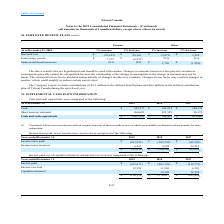From Loral Space Communications's financial document, How much does the company expect to make contributions to to the defined benefit plans and the defined contribution plan respectively during the next fiscal year? The document shows two values: $5.1 million and $0.6 million. From the document: "s of $5.1 million to the defined benefit plans and $0.6 million to the defined contribution The Company expects to make contributions of $5.1 million ..." Also, How much would the pension change if there is a 1% increase and a 1% decrease respectively in the discount rate? The document shows two values: $(39,145) and $49,361. From the document: "Discount rate $ (39,145) $ 49,361 $ (2,471) $ 3,224 Discount rate $ (39,145) $ 49,361 $ (2,471) $ 3,224..." Also, How much would the pension change if there is a 1% increase and a 1% decrease respectively in the future salary growth? The document shows two values: $7,572 and $(6,919). From the document: "Future salary growth $ 7,572 $ (6,919) N/A N/A Future salary growth $ 7,572 $ (6,919) N/A N/A..." Also, can you calculate: What is the value of the expected defined contribution plan as a percentage of the defined benefit plan during the next fiscal year? Based on the calculation: 0.6/5.1 , the result is 11.76 (percentage). This is based on the information: "The Company expects to make contributions of $5.1 million to the defined benefit plans and $0.6 million to the defined contribution of $5.1 million to the defined benefit plans and $0.6 million to the..." The key data points involved are: 0.6, 5.1. Also, can you calculate: What is the difference in pension amount if the future salary growth had a 1% increase and a 1% decrease? Based on the calculation: 7,572 - (6,919) , the result is 14491. This is based on the information: "Future salary growth $ 7,572 $ (6,919) N/A N/A Future salary growth $ 7,572 $ (6,919) N/A N/A..." The key data points involved are: 6,919, 7,572. Also, can you calculate: What is the difference in pension amount if the discount rate had a 1% increase and a 1% decrease? Based on the calculation: 49,361 - (39,145) , the result is 88506. This is based on the information: "Discount rate $ (39,145) $ 49,361 $ (2,471) $ 3,224 Discount rate $ (39,145) $ 49,361 $ (2,471) $ 3,224..." The key data points involved are: 39,145, 49,361. 